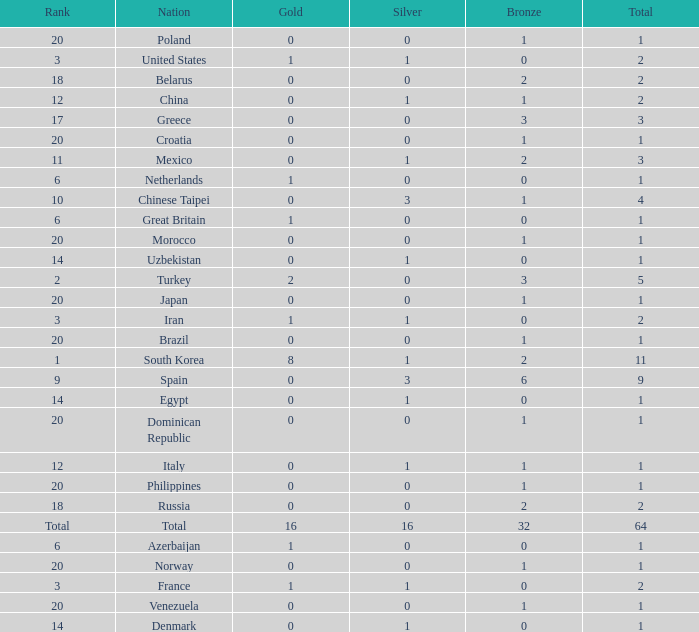What is the average number of bronze of the nation with more than 1 gold and 1 silver medal? 2.0. 